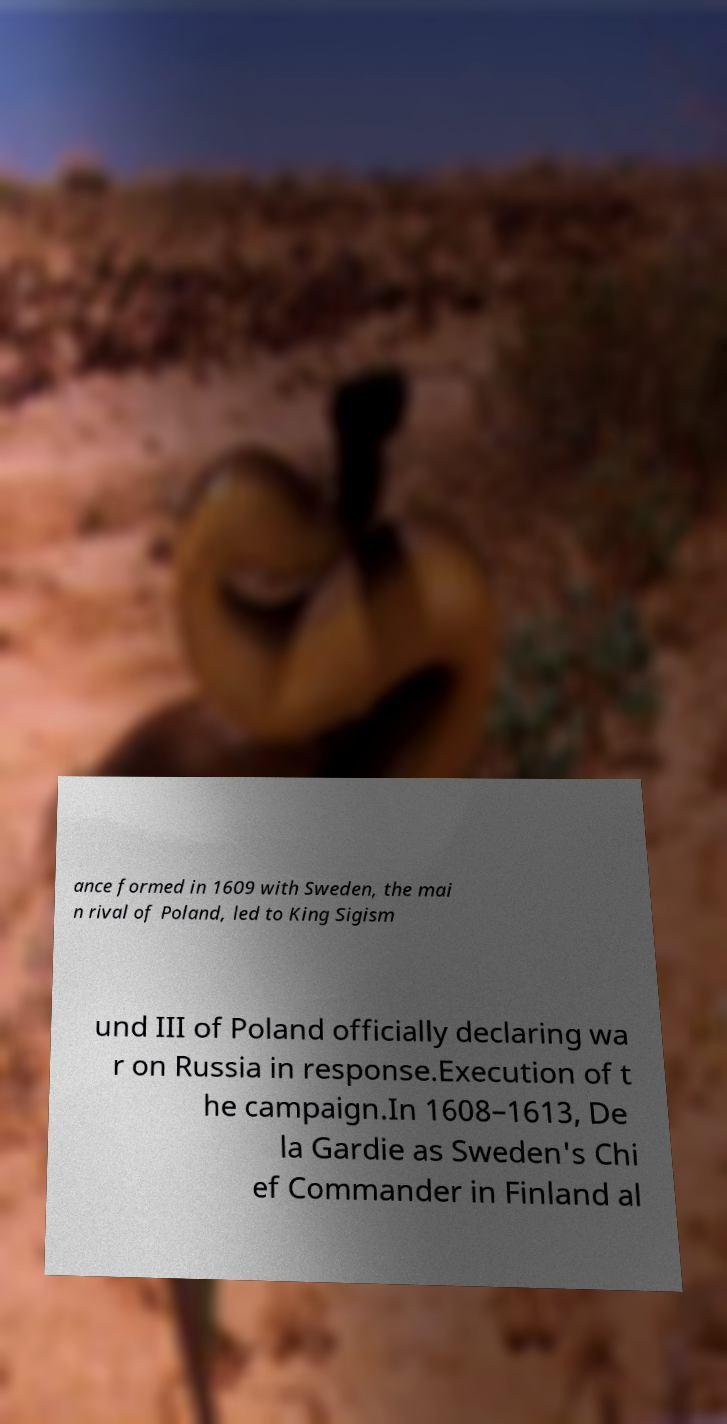Could you extract and type out the text from this image? ance formed in 1609 with Sweden, the mai n rival of Poland, led to King Sigism und III of Poland officially declaring wa r on Russia in response.Execution of t he campaign.In 1608–1613, De la Gardie as Sweden's Chi ef Commander in Finland al 